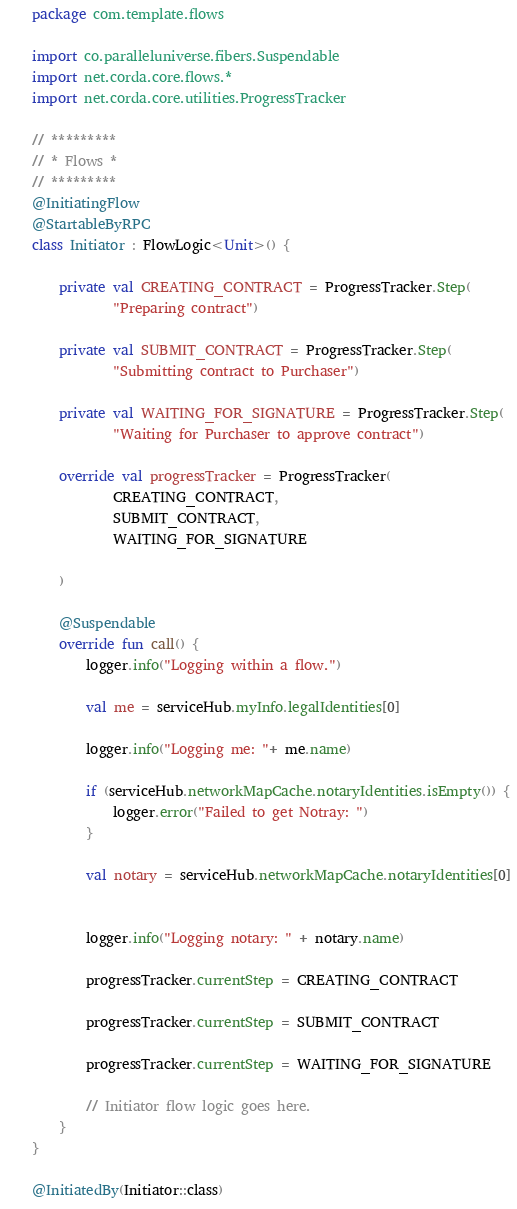<code> <loc_0><loc_0><loc_500><loc_500><_Kotlin_>package com.template.flows

import co.paralleluniverse.fibers.Suspendable
import net.corda.core.flows.*
import net.corda.core.utilities.ProgressTracker

// *********
// * Flows *
// *********
@InitiatingFlow
@StartableByRPC
class Initiator : FlowLogic<Unit>() {

    private val CREATING_CONTRACT = ProgressTracker.Step(
            "Preparing contract")

    private val SUBMIT_CONTRACT = ProgressTracker.Step(
            "Submitting contract to Purchaser")

    private val WAITING_FOR_SIGNATURE = ProgressTracker.Step(
            "Waiting for Purchaser to approve contract")

    override val progressTracker = ProgressTracker(
            CREATING_CONTRACT,
            SUBMIT_CONTRACT,
            WAITING_FOR_SIGNATURE

    )

    @Suspendable
    override fun call() {
        logger.info("Logging within a flow.")

        val me = serviceHub.myInfo.legalIdentities[0]

        logger.info("Logging me: "+ me.name)

        if (serviceHub.networkMapCache.notaryIdentities.isEmpty()) {
            logger.error("Failed to get Notray: ")
        }

        val notary = serviceHub.networkMapCache.notaryIdentities[0]


        logger.info("Logging notary: " + notary.name)

        progressTracker.currentStep = CREATING_CONTRACT

        progressTracker.currentStep = SUBMIT_CONTRACT

        progressTracker.currentStep = WAITING_FOR_SIGNATURE

        // Initiator flow logic goes here.
    }
}

@InitiatedBy(Initiator::class)</code> 